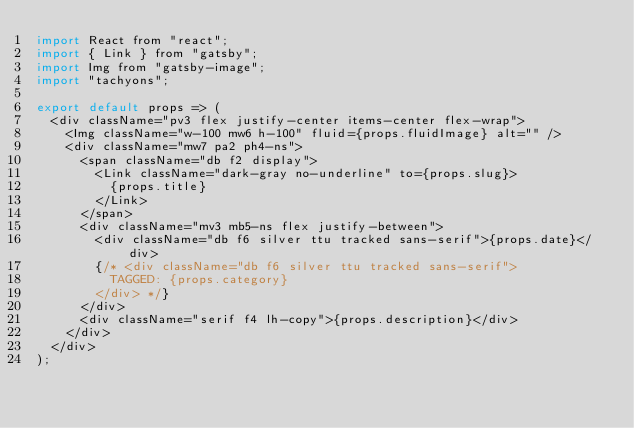<code> <loc_0><loc_0><loc_500><loc_500><_JavaScript_>import React from "react";
import { Link } from "gatsby";
import Img from "gatsby-image";
import "tachyons";

export default props => (
  <div className="pv3 flex justify-center items-center flex-wrap">
    <Img className="w-100 mw6 h-100" fluid={props.fluidImage} alt="" />
    <div className="mw7 pa2 ph4-ns">
      <span className="db f2 display">
        <Link className="dark-gray no-underline" to={props.slug}>
          {props.title}
        </Link>
      </span>
      <div className="mv3 mb5-ns flex justify-between">
        <div className="db f6 silver ttu tracked sans-serif">{props.date}</div>
        {/* <div className="db f6 silver ttu tracked sans-serif">
          TAGGED: {props.category}
        </div> */}
      </div>
      <div className="serif f4 lh-copy">{props.description}</div>
    </div>
  </div>
);
</code> 